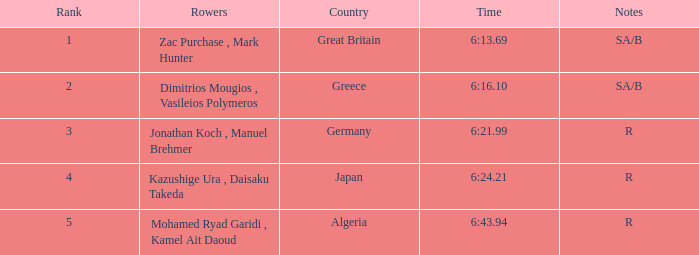What are the notes with the time 6:24.21? R. 